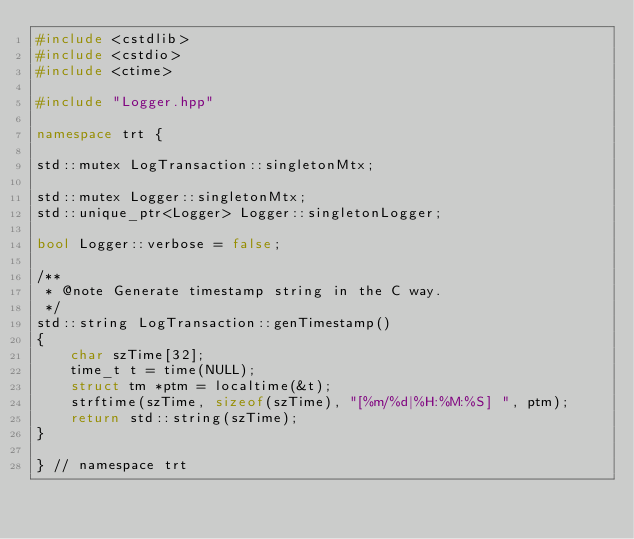Convert code to text. <code><loc_0><loc_0><loc_500><loc_500><_C++_>#include <cstdlib>
#include <cstdio>
#include <ctime>

#include "Logger.hpp"

namespace trt {

std::mutex LogTransaction::singletonMtx;

std::mutex Logger::singletonMtx;
std::unique_ptr<Logger> Logger::singletonLogger;

bool Logger::verbose = false;

/**
 * @note Generate timestamp string in the C way.
 */
std::string LogTransaction::genTimestamp()
{
    char szTime[32];
    time_t t = time(NULL);
    struct tm *ptm = localtime(&t);
    strftime(szTime, sizeof(szTime), "[%m/%d|%H:%M:%S] ", ptm);
    return std::string(szTime);
}

} // namespace trt
</code> 